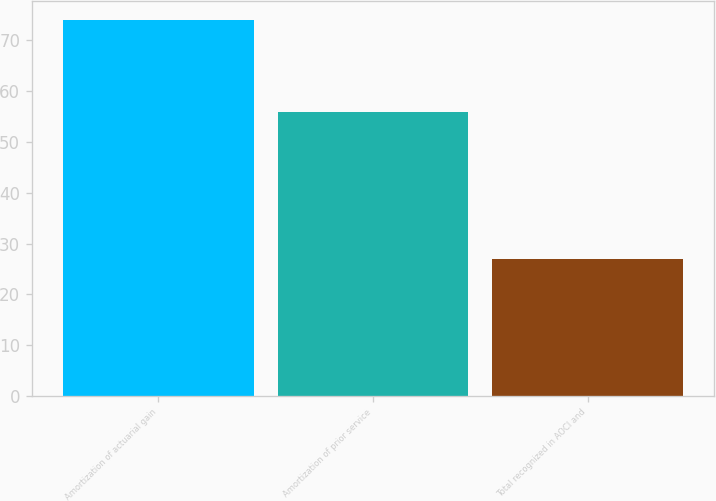Convert chart to OTSL. <chart><loc_0><loc_0><loc_500><loc_500><bar_chart><fcel>Amortization of actuarial gain<fcel>Amortization of prior service<fcel>Total recognized in AOCI and<nl><fcel>74<fcel>56<fcel>27<nl></chart> 